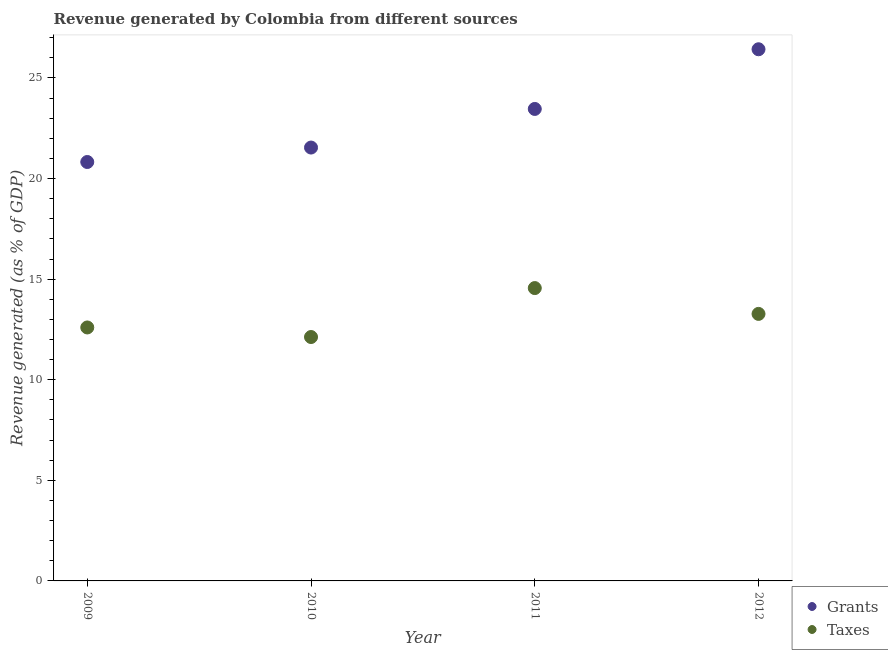How many different coloured dotlines are there?
Make the answer very short. 2. What is the revenue generated by taxes in 2011?
Your answer should be compact. 14.56. Across all years, what is the maximum revenue generated by grants?
Provide a succinct answer. 26.43. Across all years, what is the minimum revenue generated by grants?
Provide a short and direct response. 20.82. In which year was the revenue generated by taxes maximum?
Your answer should be very brief. 2011. In which year was the revenue generated by grants minimum?
Your answer should be compact. 2009. What is the total revenue generated by grants in the graph?
Your answer should be compact. 92.25. What is the difference between the revenue generated by grants in 2009 and that in 2010?
Your answer should be very brief. -0.72. What is the difference between the revenue generated by taxes in 2010 and the revenue generated by grants in 2012?
Your response must be concise. -14.3. What is the average revenue generated by taxes per year?
Your response must be concise. 13.14. In the year 2012, what is the difference between the revenue generated by grants and revenue generated by taxes?
Offer a very short reply. 13.15. In how many years, is the revenue generated by taxes greater than 26 %?
Offer a terse response. 0. What is the ratio of the revenue generated by taxes in 2011 to that in 2012?
Offer a very short reply. 1.1. What is the difference between the highest and the second highest revenue generated by grants?
Your answer should be compact. 2.97. What is the difference between the highest and the lowest revenue generated by taxes?
Provide a succinct answer. 2.43. In how many years, is the revenue generated by taxes greater than the average revenue generated by taxes taken over all years?
Keep it short and to the point. 2. Is the sum of the revenue generated by grants in 2009 and 2012 greater than the maximum revenue generated by taxes across all years?
Provide a succinct answer. Yes. Is the revenue generated by taxes strictly greater than the revenue generated by grants over the years?
Offer a very short reply. No. Is the revenue generated by grants strictly less than the revenue generated by taxes over the years?
Give a very brief answer. No. How many years are there in the graph?
Give a very brief answer. 4. Are the values on the major ticks of Y-axis written in scientific E-notation?
Offer a very short reply. No. What is the title of the graph?
Your answer should be compact. Revenue generated by Colombia from different sources. Does "Quasi money growth" appear as one of the legend labels in the graph?
Your answer should be compact. No. What is the label or title of the Y-axis?
Provide a succinct answer. Revenue generated (as % of GDP). What is the Revenue generated (as % of GDP) of Grants in 2009?
Give a very brief answer. 20.82. What is the Revenue generated (as % of GDP) in Taxes in 2009?
Keep it short and to the point. 12.6. What is the Revenue generated (as % of GDP) in Grants in 2010?
Your response must be concise. 21.54. What is the Revenue generated (as % of GDP) of Taxes in 2010?
Offer a very short reply. 12.12. What is the Revenue generated (as % of GDP) in Grants in 2011?
Provide a short and direct response. 23.46. What is the Revenue generated (as % of GDP) in Taxes in 2011?
Provide a succinct answer. 14.56. What is the Revenue generated (as % of GDP) of Grants in 2012?
Your answer should be very brief. 26.43. What is the Revenue generated (as % of GDP) in Taxes in 2012?
Your answer should be compact. 13.27. Across all years, what is the maximum Revenue generated (as % of GDP) of Grants?
Make the answer very short. 26.43. Across all years, what is the maximum Revenue generated (as % of GDP) of Taxes?
Your answer should be very brief. 14.56. Across all years, what is the minimum Revenue generated (as % of GDP) in Grants?
Provide a short and direct response. 20.82. Across all years, what is the minimum Revenue generated (as % of GDP) in Taxes?
Your answer should be compact. 12.12. What is the total Revenue generated (as % of GDP) in Grants in the graph?
Offer a terse response. 92.25. What is the total Revenue generated (as % of GDP) of Taxes in the graph?
Give a very brief answer. 52.55. What is the difference between the Revenue generated (as % of GDP) of Grants in 2009 and that in 2010?
Your answer should be very brief. -0.72. What is the difference between the Revenue generated (as % of GDP) of Taxes in 2009 and that in 2010?
Keep it short and to the point. 0.48. What is the difference between the Revenue generated (as % of GDP) in Grants in 2009 and that in 2011?
Your answer should be compact. -2.64. What is the difference between the Revenue generated (as % of GDP) in Taxes in 2009 and that in 2011?
Your answer should be compact. -1.96. What is the difference between the Revenue generated (as % of GDP) in Grants in 2009 and that in 2012?
Your answer should be compact. -5.6. What is the difference between the Revenue generated (as % of GDP) in Taxes in 2009 and that in 2012?
Ensure brevity in your answer.  -0.67. What is the difference between the Revenue generated (as % of GDP) of Grants in 2010 and that in 2011?
Give a very brief answer. -1.92. What is the difference between the Revenue generated (as % of GDP) in Taxes in 2010 and that in 2011?
Make the answer very short. -2.43. What is the difference between the Revenue generated (as % of GDP) in Grants in 2010 and that in 2012?
Make the answer very short. -4.89. What is the difference between the Revenue generated (as % of GDP) of Taxes in 2010 and that in 2012?
Your response must be concise. -1.15. What is the difference between the Revenue generated (as % of GDP) in Grants in 2011 and that in 2012?
Ensure brevity in your answer.  -2.97. What is the difference between the Revenue generated (as % of GDP) in Taxes in 2011 and that in 2012?
Provide a succinct answer. 1.28. What is the difference between the Revenue generated (as % of GDP) of Grants in 2009 and the Revenue generated (as % of GDP) of Taxes in 2010?
Keep it short and to the point. 8.7. What is the difference between the Revenue generated (as % of GDP) of Grants in 2009 and the Revenue generated (as % of GDP) of Taxes in 2011?
Make the answer very short. 6.27. What is the difference between the Revenue generated (as % of GDP) of Grants in 2009 and the Revenue generated (as % of GDP) of Taxes in 2012?
Provide a short and direct response. 7.55. What is the difference between the Revenue generated (as % of GDP) of Grants in 2010 and the Revenue generated (as % of GDP) of Taxes in 2011?
Offer a terse response. 6.98. What is the difference between the Revenue generated (as % of GDP) in Grants in 2010 and the Revenue generated (as % of GDP) in Taxes in 2012?
Provide a succinct answer. 8.27. What is the difference between the Revenue generated (as % of GDP) of Grants in 2011 and the Revenue generated (as % of GDP) of Taxes in 2012?
Give a very brief answer. 10.19. What is the average Revenue generated (as % of GDP) of Grants per year?
Keep it short and to the point. 23.06. What is the average Revenue generated (as % of GDP) of Taxes per year?
Your response must be concise. 13.14. In the year 2009, what is the difference between the Revenue generated (as % of GDP) in Grants and Revenue generated (as % of GDP) in Taxes?
Make the answer very short. 8.22. In the year 2010, what is the difference between the Revenue generated (as % of GDP) of Grants and Revenue generated (as % of GDP) of Taxes?
Offer a terse response. 9.42. In the year 2011, what is the difference between the Revenue generated (as % of GDP) of Grants and Revenue generated (as % of GDP) of Taxes?
Keep it short and to the point. 8.9. In the year 2012, what is the difference between the Revenue generated (as % of GDP) in Grants and Revenue generated (as % of GDP) in Taxes?
Offer a very short reply. 13.15. What is the ratio of the Revenue generated (as % of GDP) of Grants in 2009 to that in 2010?
Make the answer very short. 0.97. What is the ratio of the Revenue generated (as % of GDP) of Taxes in 2009 to that in 2010?
Your response must be concise. 1.04. What is the ratio of the Revenue generated (as % of GDP) in Grants in 2009 to that in 2011?
Offer a terse response. 0.89. What is the ratio of the Revenue generated (as % of GDP) in Taxes in 2009 to that in 2011?
Offer a terse response. 0.87. What is the ratio of the Revenue generated (as % of GDP) in Grants in 2009 to that in 2012?
Your response must be concise. 0.79. What is the ratio of the Revenue generated (as % of GDP) in Taxes in 2009 to that in 2012?
Make the answer very short. 0.95. What is the ratio of the Revenue generated (as % of GDP) of Grants in 2010 to that in 2011?
Keep it short and to the point. 0.92. What is the ratio of the Revenue generated (as % of GDP) of Taxes in 2010 to that in 2011?
Your answer should be very brief. 0.83. What is the ratio of the Revenue generated (as % of GDP) in Grants in 2010 to that in 2012?
Offer a terse response. 0.82. What is the ratio of the Revenue generated (as % of GDP) of Taxes in 2010 to that in 2012?
Offer a terse response. 0.91. What is the ratio of the Revenue generated (as % of GDP) of Grants in 2011 to that in 2012?
Provide a short and direct response. 0.89. What is the ratio of the Revenue generated (as % of GDP) in Taxes in 2011 to that in 2012?
Offer a very short reply. 1.1. What is the difference between the highest and the second highest Revenue generated (as % of GDP) of Grants?
Ensure brevity in your answer.  2.97. What is the difference between the highest and the second highest Revenue generated (as % of GDP) in Taxes?
Give a very brief answer. 1.28. What is the difference between the highest and the lowest Revenue generated (as % of GDP) of Grants?
Offer a terse response. 5.6. What is the difference between the highest and the lowest Revenue generated (as % of GDP) of Taxes?
Keep it short and to the point. 2.43. 